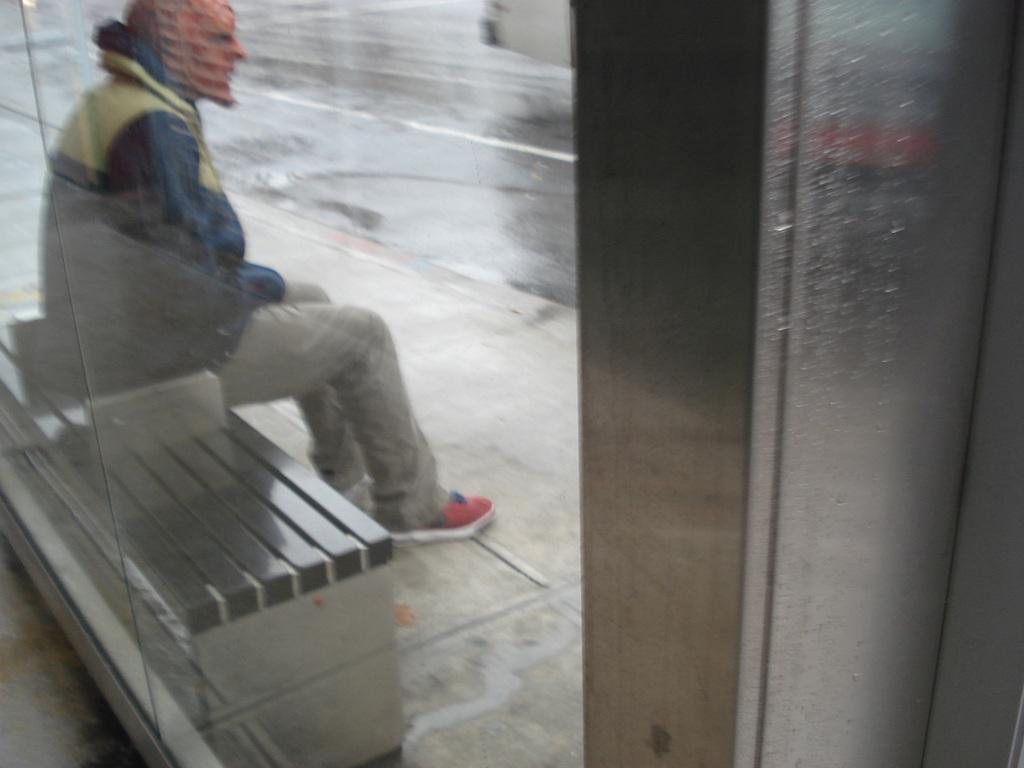Could you give a brief overview of what you see in this image? In the image we can see there is a person sitting on the bench. 